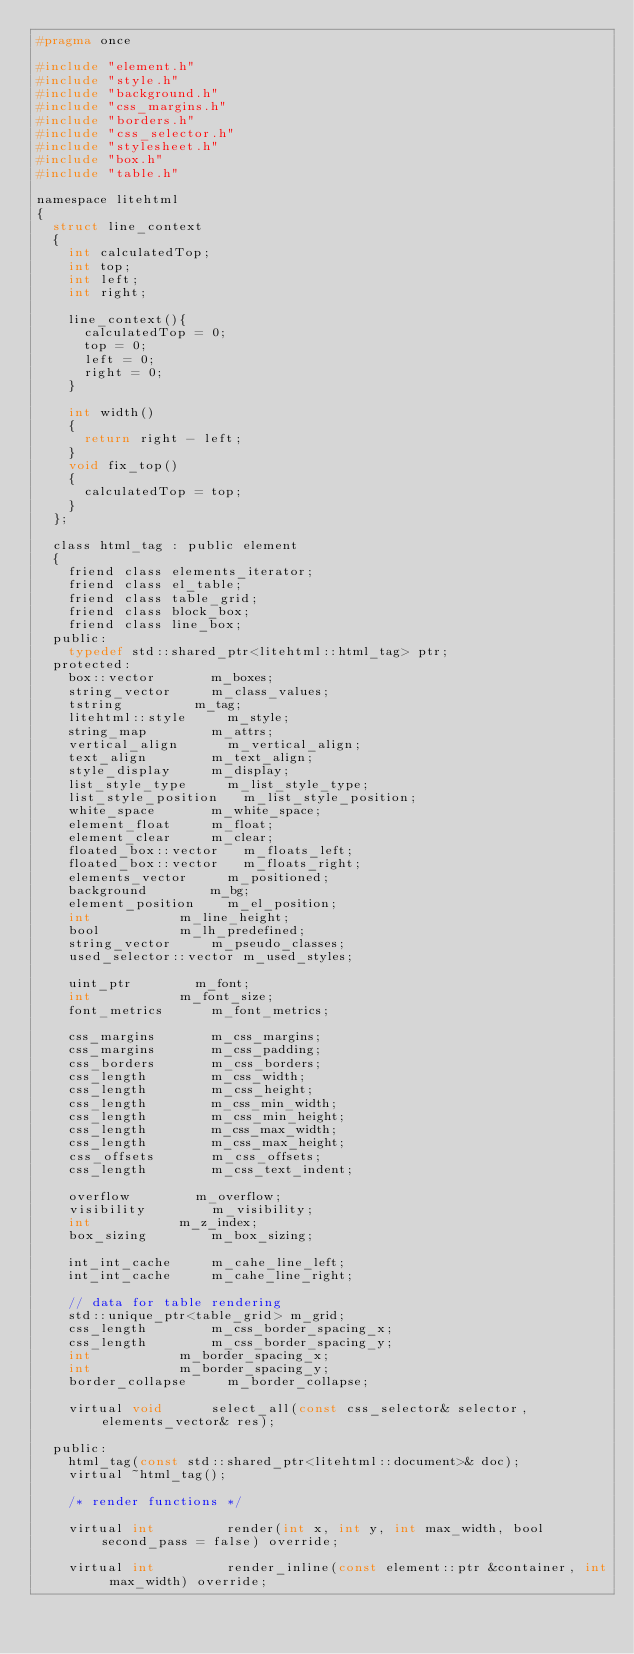<code> <loc_0><loc_0><loc_500><loc_500><_C_>#pragma once

#include "element.h"
#include "style.h"
#include "background.h"
#include "css_margins.h"
#include "borders.h"
#include "css_selector.h"
#include "stylesheet.h"
#include "box.h"
#include "table.h"

namespace litehtml
{
	struct line_context
	{
		int calculatedTop;
		int top;
		int left;
		int right;
		
		line_context(){
			calculatedTop = 0;
			top = 0;
			left = 0;
			right = 0;
		}

		int width()
		{
			return right - left;
		}
		void fix_top()
		{
			calculatedTop = top;
		}
	};

	class html_tag : public element
	{
		friend class elements_iterator;
		friend class el_table;
		friend class table_grid;
		friend class block_box;
		friend class line_box;
	public:
		typedef std::shared_ptr<litehtml::html_tag>	ptr;
	protected:
		box::vector				m_boxes;
		string_vector			m_class_values;
		tstring					m_tag;
		litehtml::style			m_style;
		string_map				m_attrs;
		vertical_align			m_vertical_align;
		text_align				m_text_align;
		style_display			m_display;
		list_style_type			m_list_style_type;
		list_style_position		m_list_style_position;
		white_space				m_white_space;
		element_float			m_float;
		element_clear			m_clear;
		floated_box::vector		m_floats_left;
		floated_box::vector		m_floats_right;
		elements_vector			m_positioned;
		background				m_bg;
		element_position		m_el_position;
		int						m_line_height;
		bool					m_lh_predefined;
		string_vector			m_pseudo_classes;
		used_selector::vector	m_used_styles;		
		
		uint_ptr				m_font;
		int						m_font_size;
		font_metrics			m_font_metrics;

		css_margins				m_css_margins;
		css_margins				m_css_padding;
		css_borders				m_css_borders;
		css_length				m_css_width;
		css_length				m_css_height;
		css_length				m_css_min_width;
		css_length				m_css_min_height;
		css_length				m_css_max_width;
		css_length				m_css_max_height;
		css_offsets				m_css_offsets;
		css_length				m_css_text_indent;

		overflow				m_overflow;
		visibility				m_visibility;
		int						m_z_index;
		box_sizing				m_box_sizing;

		int_int_cache			m_cahe_line_left;
		int_int_cache			m_cahe_line_right;

		// data for table rendering
		std::unique_ptr<table_grid>	m_grid;
		css_length				m_css_border_spacing_x;
		css_length				m_css_border_spacing_y;
		int						m_border_spacing_x;
		int						m_border_spacing_y;
		border_collapse			m_border_collapse;

		virtual void			select_all(const css_selector& selector, elements_vector& res);

	public:
		html_tag(const std::shared_ptr<litehtml::document>& doc);
		virtual ~html_tag();

		/* render functions */

		virtual int					render(int x, int y, int max_width, bool second_pass = false) override;

		virtual int					render_inline(const element::ptr &container, int max_width) override;</code> 